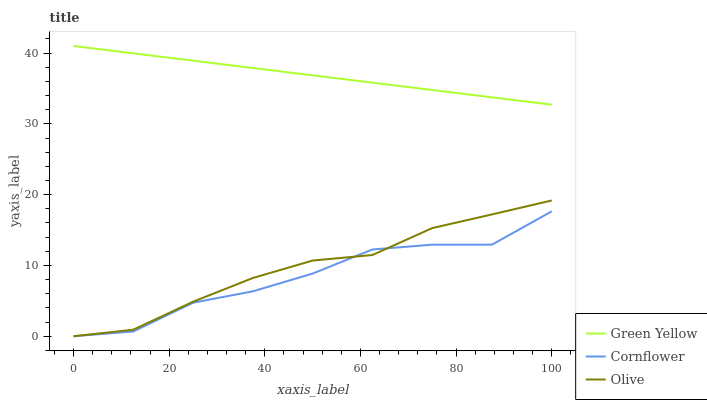Does Green Yellow have the minimum area under the curve?
Answer yes or no. No. Does Cornflower have the maximum area under the curve?
Answer yes or no. No. Is Cornflower the smoothest?
Answer yes or no. No. Is Green Yellow the roughest?
Answer yes or no. No. Does Green Yellow have the lowest value?
Answer yes or no. No. Does Cornflower have the highest value?
Answer yes or no. No. Is Olive less than Green Yellow?
Answer yes or no. Yes. Is Green Yellow greater than Cornflower?
Answer yes or no. Yes. Does Olive intersect Green Yellow?
Answer yes or no. No. 